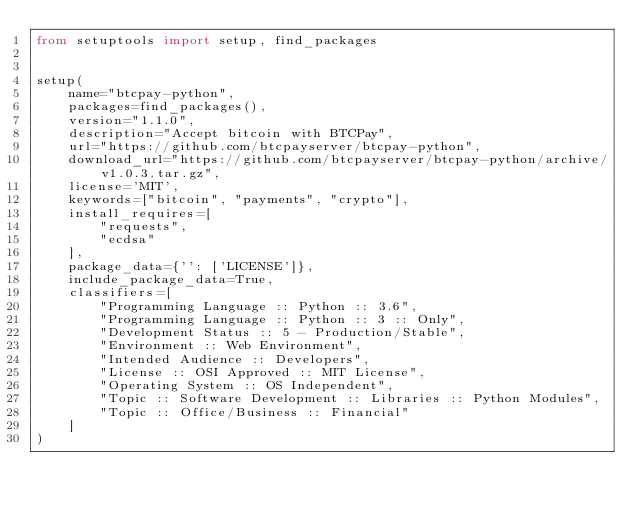<code> <loc_0><loc_0><loc_500><loc_500><_Python_>from setuptools import setup, find_packages


setup(
    name="btcpay-python",
    packages=find_packages(),
    version="1.1.0",
    description="Accept bitcoin with BTCPay",
    url="https://github.com/btcpayserver/btcpay-python",
    download_url="https://github.com/btcpayserver/btcpay-python/archive/v1.0.3.tar.gz",
    license='MIT',
    keywords=["bitcoin", "payments", "crypto"],
    install_requires=[
        "requests",
        "ecdsa"
    ],
    package_data={'': ['LICENSE']},
    include_package_data=True,
    classifiers=[
        "Programming Language :: Python :: 3.6",
        "Programming Language :: Python :: 3 :: Only",
        "Development Status :: 5 - Production/Stable",
        "Environment :: Web Environment",
        "Intended Audience :: Developers",
        "License :: OSI Approved :: MIT License",
        "Operating System :: OS Independent",
        "Topic :: Software Development :: Libraries :: Python Modules",
        "Topic :: Office/Business :: Financial"
    ]
)
</code> 